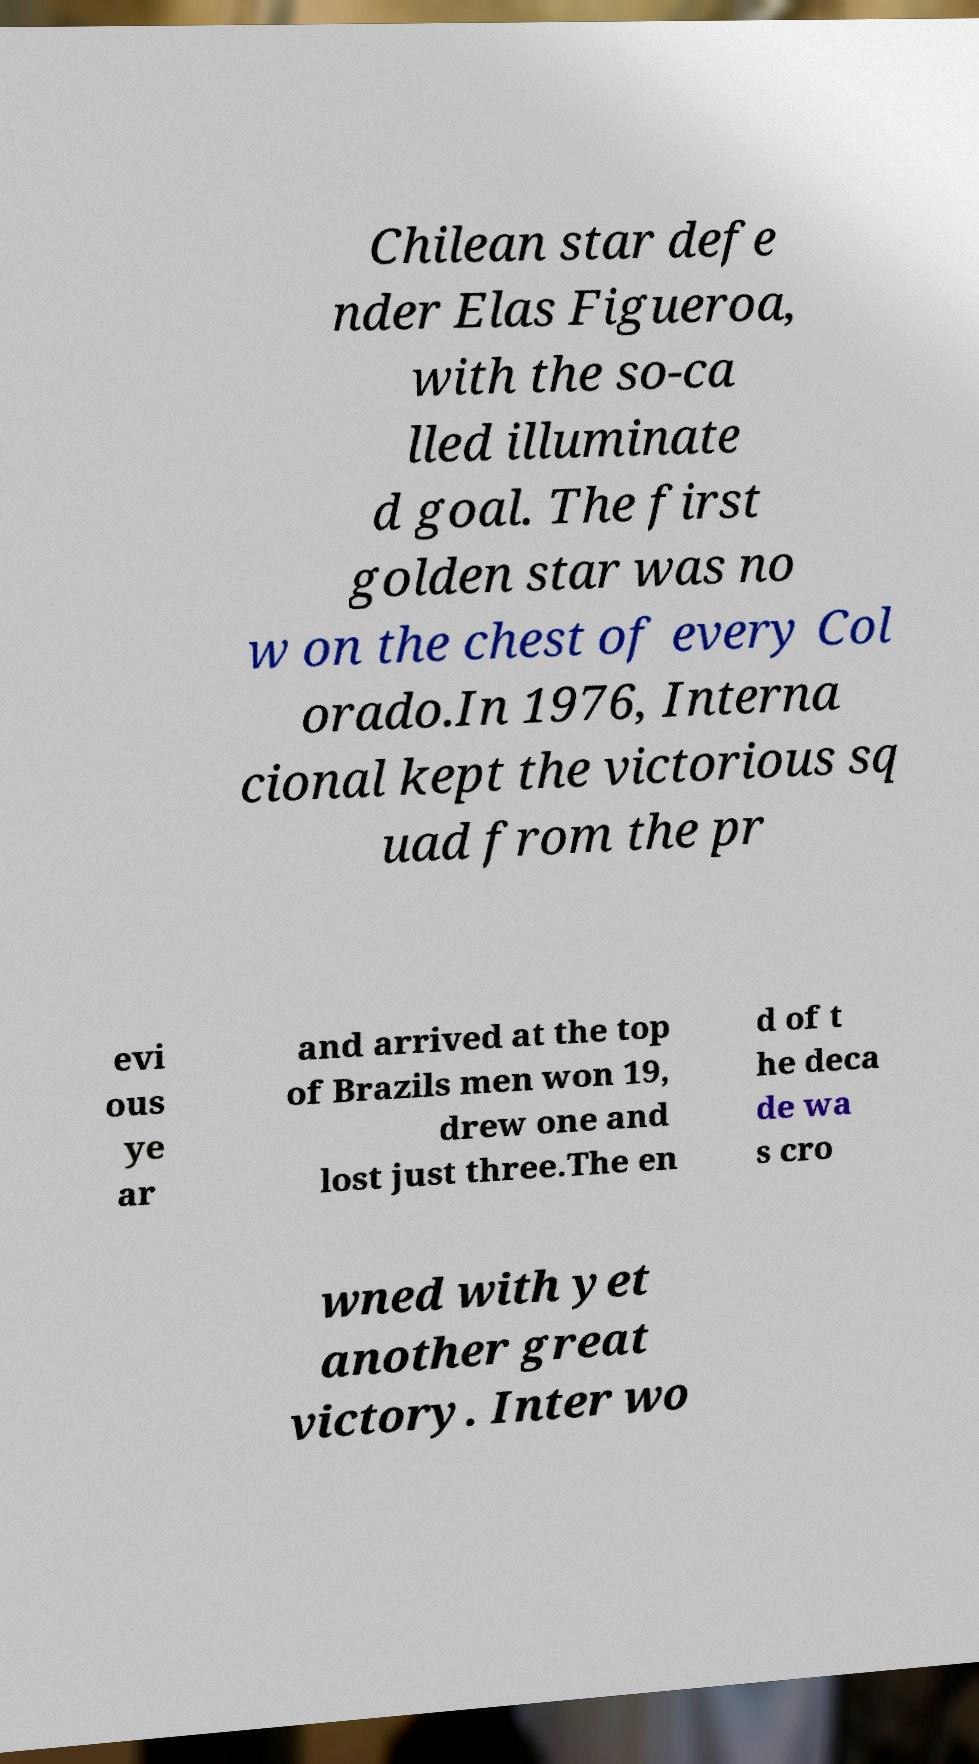For documentation purposes, I need the text within this image transcribed. Could you provide that? Chilean star defe nder Elas Figueroa, with the so-ca lled illuminate d goal. The first golden star was no w on the chest of every Col orado.In 1976, Interna cional kept the victorious sq uad from the pr evi ous ye ar and arrived at the top of Brazils men won 19, drew one and lost just three.The en d of t he deca de wa s cro wned with yet another great victory. Inter wo 